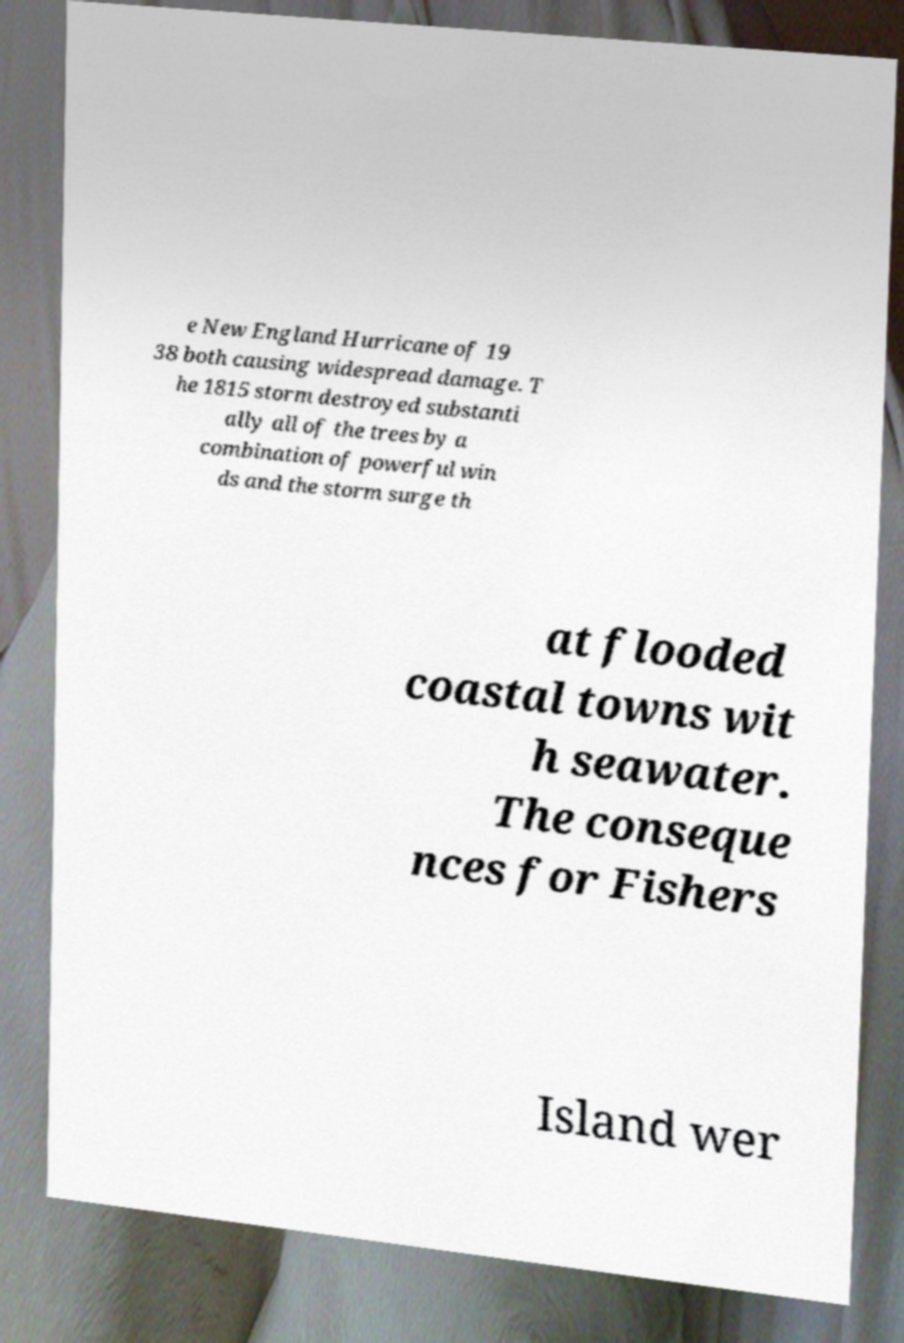Can you read and provide the text displayed in the image?This photo seems to have some interesting text. Can you extract and type it out for me? e New England Hurricane of 19 38 both causing widespread damage. T he 1815 storm destroyed substanti ally all of the trees by a combination of powerful win ds and the storm surge th at flooded coastal towns wit h seawater. The conseque nces for Fishers Island wer 